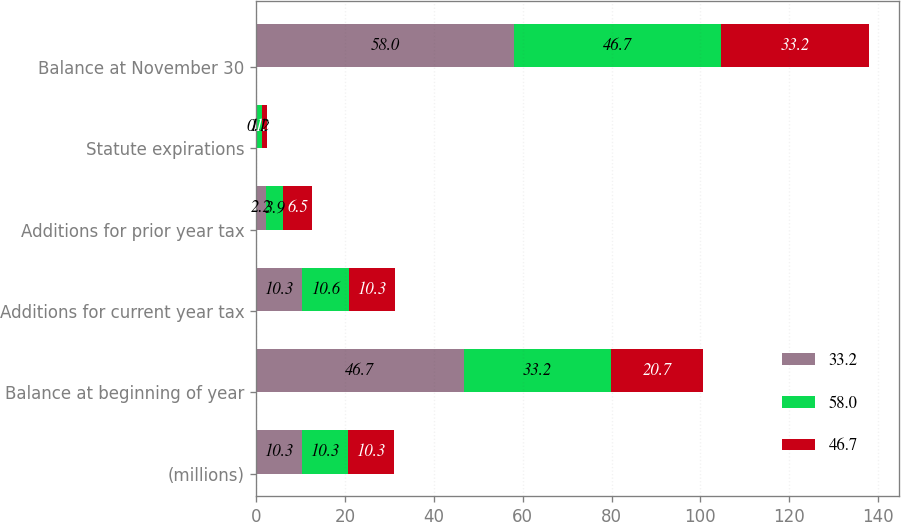Convert chart. <chart><loc_0><loc_0><loc_500><loc_500><stacked_bar_chart><ecel><fcel>(millions)<fcel>Balance at beginning of year<fcel>Additions for current year tax<fcel>Additions for prior year tax<fcel>Statute expirations<fcel>Balance at November 30<nl><fcel>33.2<fcel>10.3<fcel>46.7<fcel>10.3<fcel>2.2<fcel>0.1<fcel>58<nl><fcel>58<fcel>10.3<fcel>33.2<fcel>10.6<fcel>3.9<fcel>1.2<fcel>46.7<nl><fcel>46.7<fcel>10.3<fcel>20.7<fcel>10.3<fcel>6.5<fcel>1.2<fcel>33.2<nl></chart> 